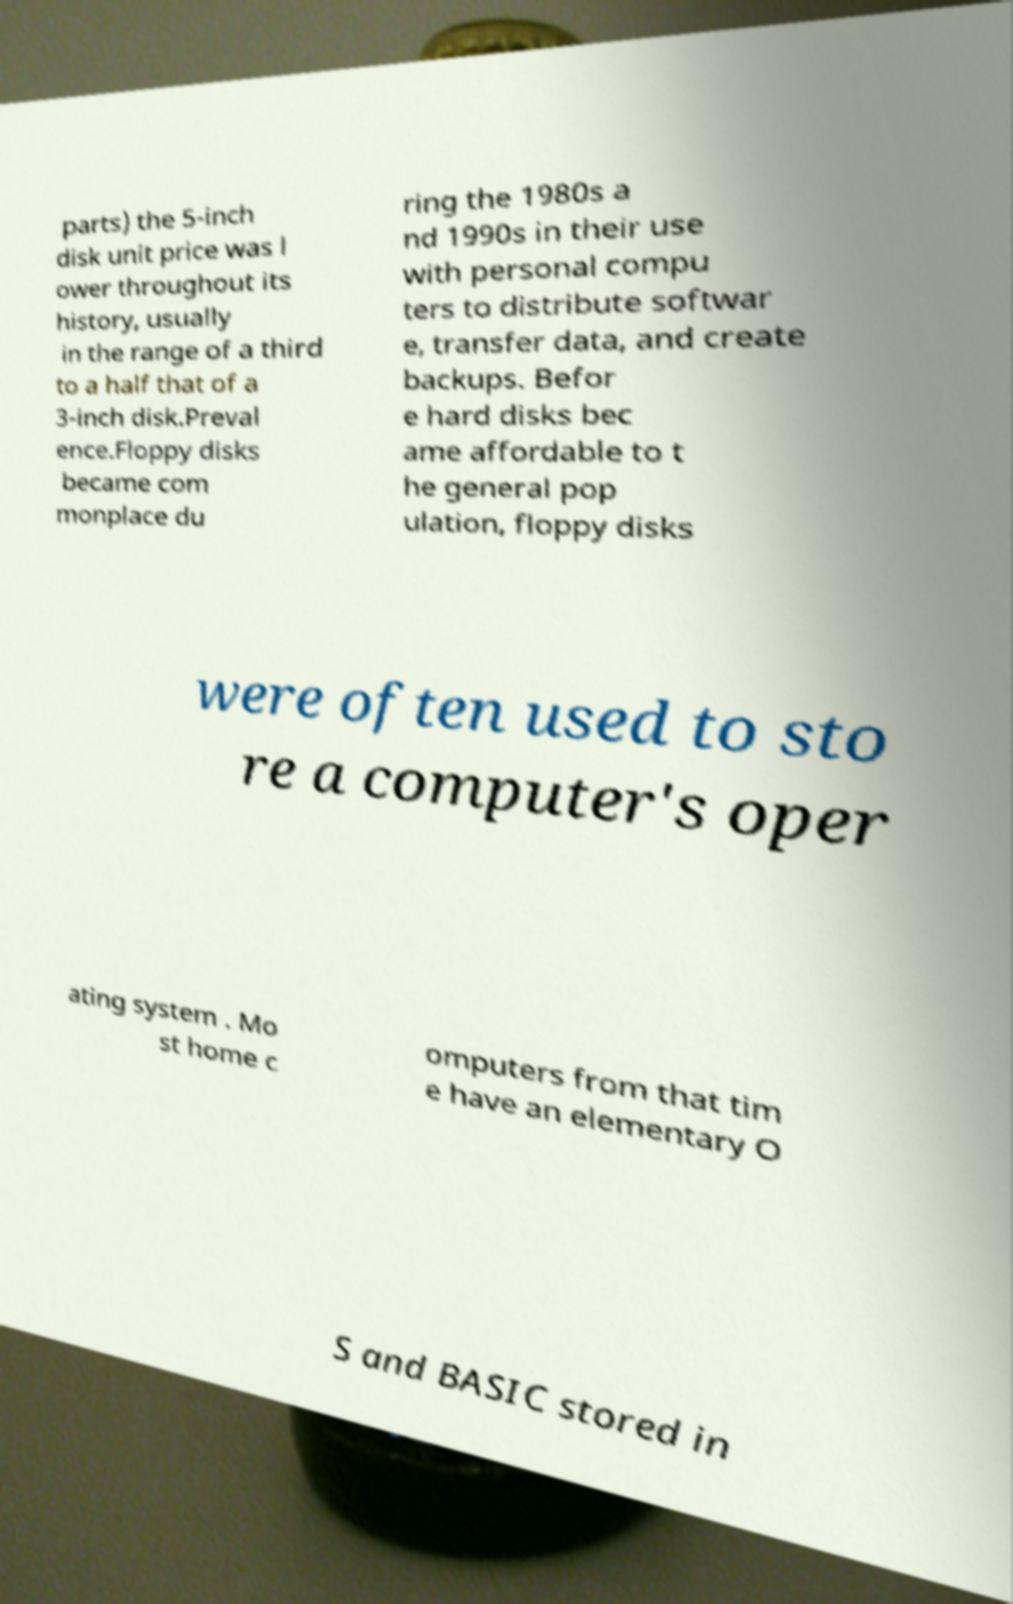There's text embedded in this image that I need extracted. Can you transcribe it verbatim? parts) the 5-inch disk unit price was l ower throughout its history, usually in the range of a third to a half that of a 3-inch disk.Preval ence.Floppy disks became com monplace du ring the 1980s a nd 1990s in their use with personal compu ters to distribute softwar e, transfer data, and create backups. Befor e hard disks bec ame affordable to t he general pop ulation, floppy disks were often used to sto re a computer's oper ating system . Mo st home c omputers from that tim e have an elementary O S and BASIC stored in 